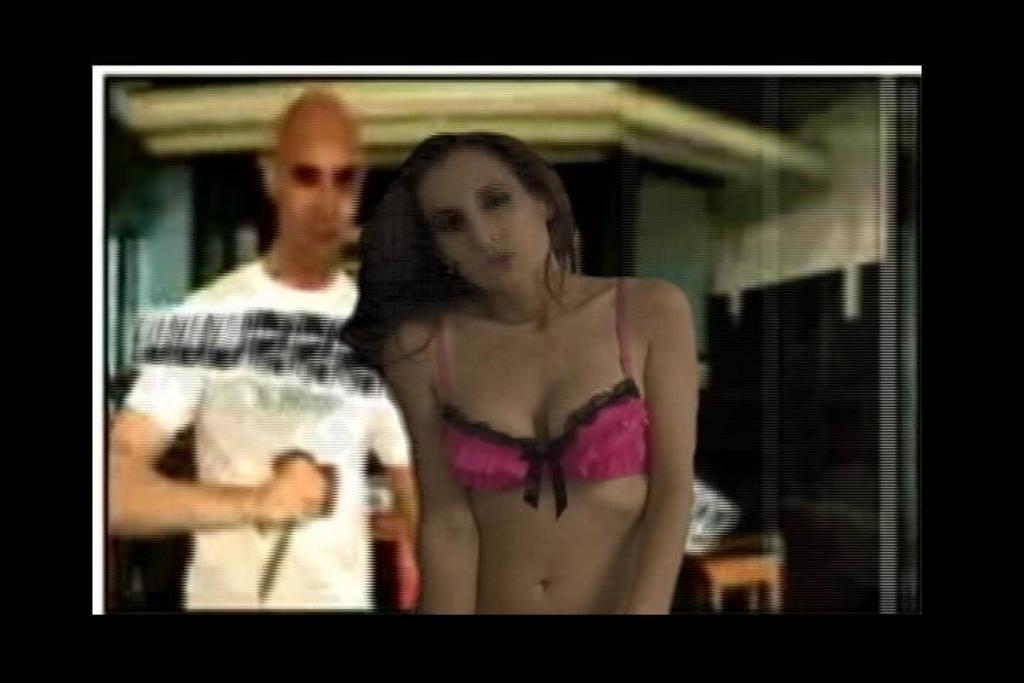How many people are in the image? There are two people in the image, a man and a woman. Where are the man and woman located in the image? The man and woman are in the center of the image. What can be seen in the background of the image? There is a wall in the background of the image. How much money is the man holding in the image? There is no money visible in the image; the man and woman are the main subjects. What type of hairstyle does the woman have in the image? The image does not provide enough detail to describe the woman's hairstyle. 